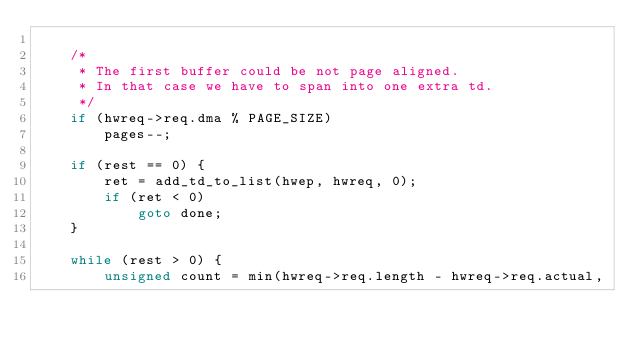Convert code to text. <code><loc_0><loc_0><loc_500><loc_500><_C_>
	/*
	 * The first buffer could be not page aligned.
	 * In that case we have to span into one extra td.
	 */
	if (hwreq->req.dma % PAGE_SIZE)
		pages--;

	if (rest == 0) {
		ret = add_td_to_list(hwep, hwreq, 0);
		if (ret < 0)
			goto done;
	}

	while (rest > 0) {
		unsigned count = min(hwreq->req.length - hwreq->req.actual,</code> 